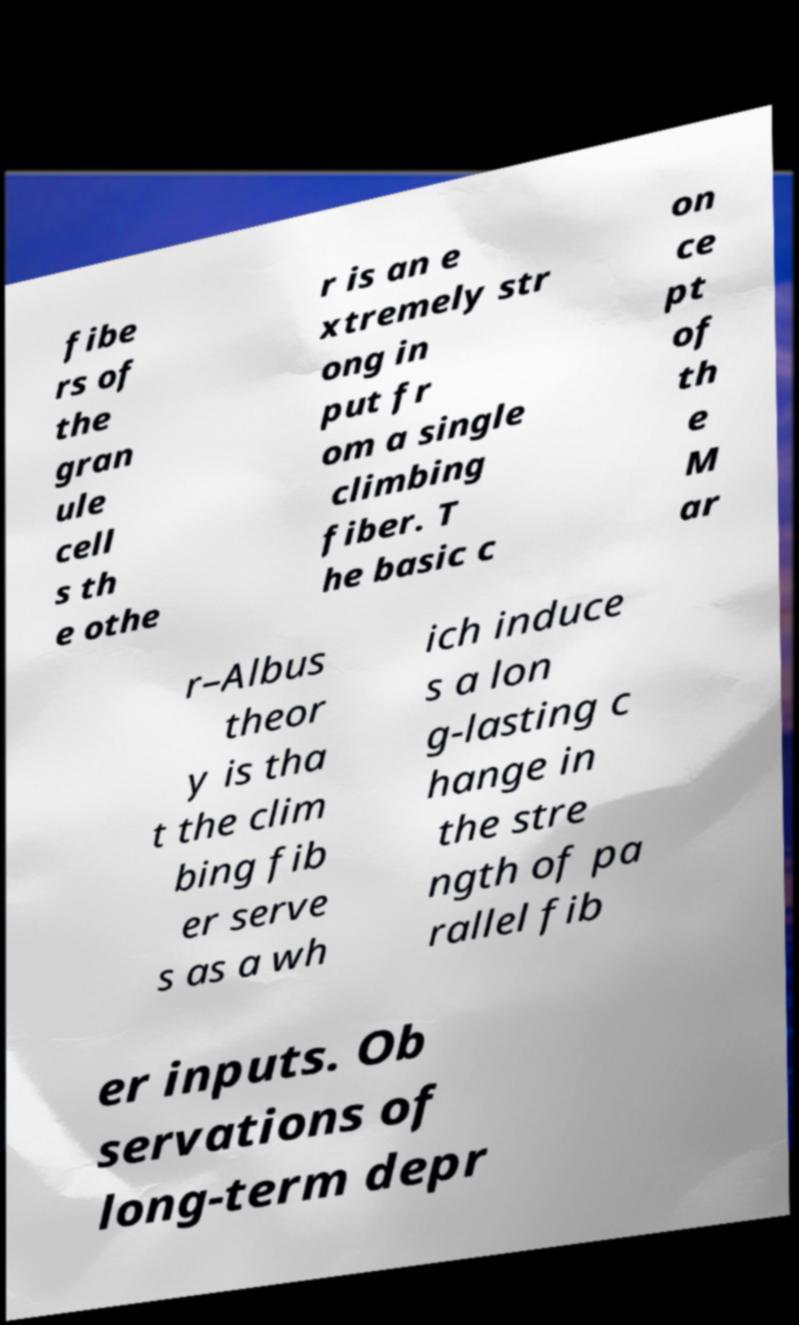Can you read and provide the text displayed in the image?This photo seems to have some interesting text. Can you extract and type it out for me? fibe rs of the gran ule cell s th e othe r is an e xtremely str ong in put fr om a single climbing fiber. T he basic c on ce pt of th e M ar r–Albus theor y is tha t the clim bing fib er serve s as a wh ich induce s a lon g-lasting c hange in the stre ngth of pa rallel fib er inputs. Ob servations of long-term depr 